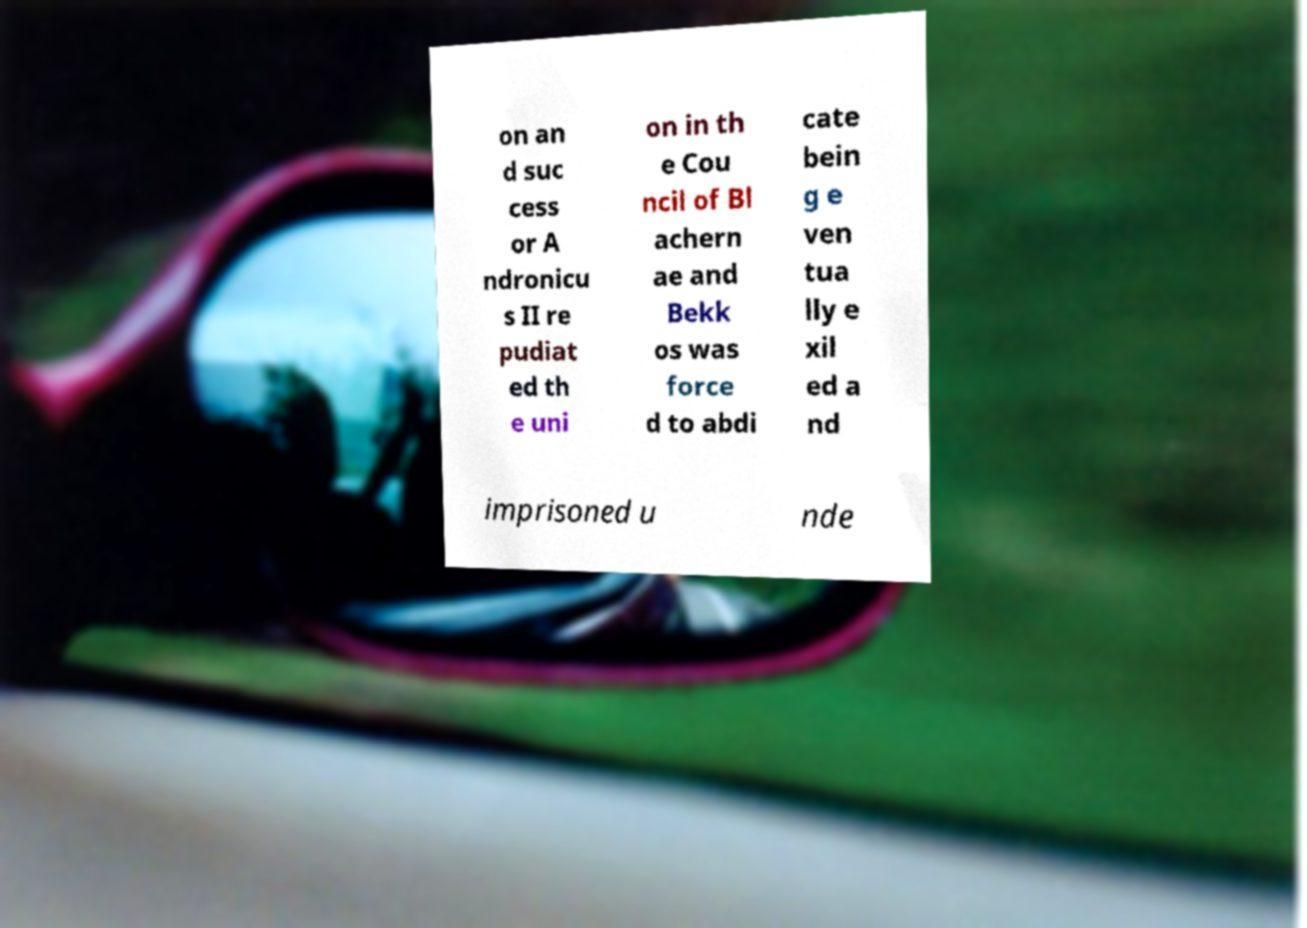Could you assist in decoding the text presented in this image and type it out clearly? on an d suc cess or A ndronicu s II re pudiat ed th e uni on in th e Cou ncil of Bl achern ae and Bekk os was force d to abdi cate bein g e ven tua lly e xil ed a nd imprisoned u nde 